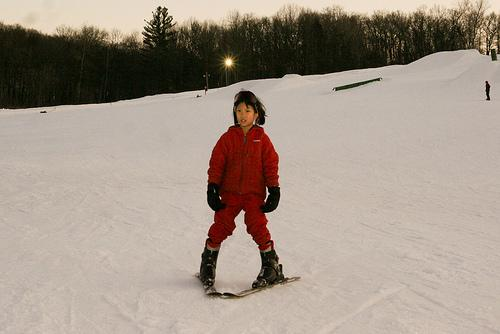What is the child standing on? snow 